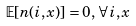Convert formula to latex. <formula><loc_0><loc_0><loc_500><loc_500>\mathbb { E } [ n ( i , x ) ] = 0 , \, \forall i , x</formula> 